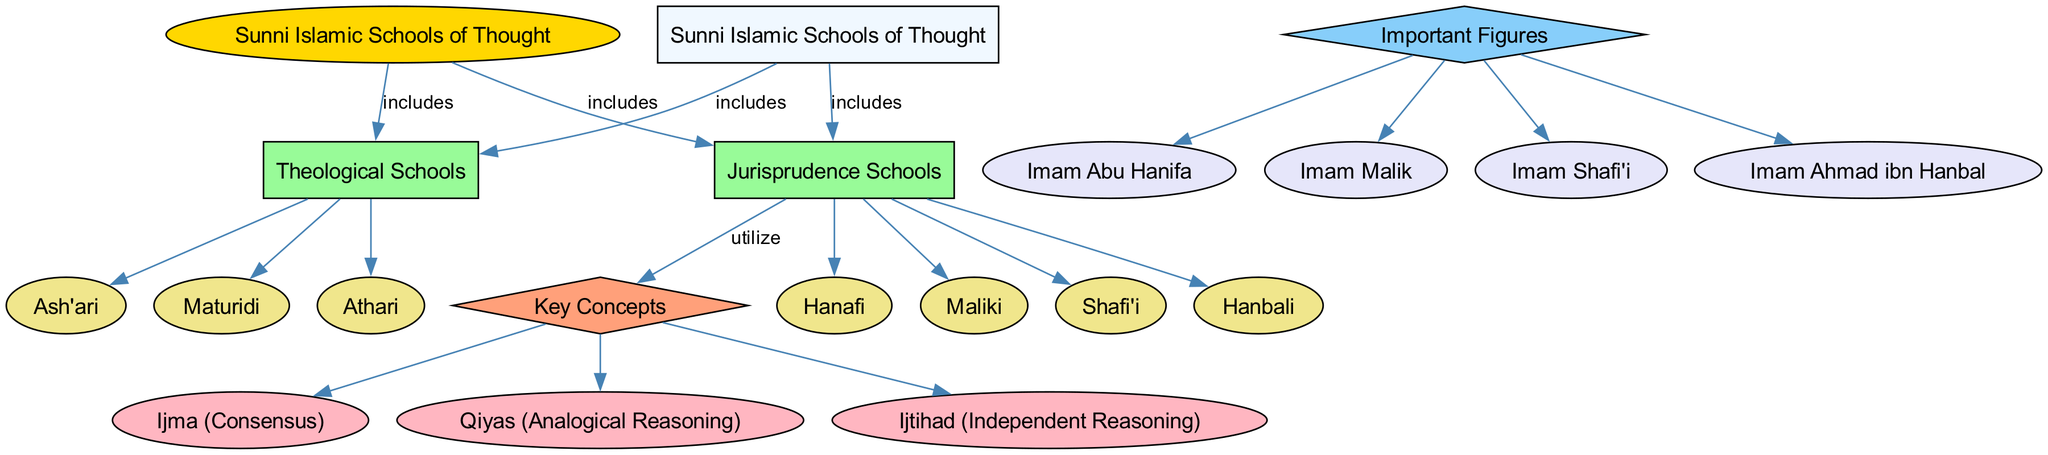What is the central concept of the diagram? The diagram's central concept is prominently positioned and labeled as "Sunni Islamic Schools of Thought." It serves as the main focal point from which other branches extend.
Answer: Sunni Islamic Schools of Thought How many main branches are included in the diagram? By counting the branches that stem from the central concept, there are two main branches: "Theological Schools" and "Jurisprudence Schools."
Answer: 2 Which school is categorized under Theological Schools? The subtypes listed under Theological Schools include "Ash'ari," "Maturidi," and "Athari." One of these subtypes is "Ash'ari," which is a clear answer to the question.
Answer: Ash'ari What are the key concepts utilized by Jurisprudence Schools? The relationships indicated in the diagram show that Jurisprudence Schools utilize key concepts such as "Ijma (Consensus)," "Qiyas (Analogical Reasoning)," and "Ijtihad (Independent Reasoning)." A straightforward answer from this list is one of the key concepts, such as "Ijma."
Answer: Ijma (Consensus) Who is a prominent figure associated with the Hanbali School? Looking at the segment of the diagram that lists important figures, "Imam Ahmad ibn Hanbal" is specifically linked to the Hanbali School, representing a key individual from that school of thought.
Answer: Imam Ahmad ibn Hanbal What type of relationship exists between the Sunni Islamic Schools of Thought and Theological Schools? The diagram illustrates a directed relationship labeled "includes" between the central concept of Sunni Islamic Schools of Thought and the branch of Theological Schools. This clearly indicates that one encompasses the other.
Answer: includes What color represents the Theological Schools in the diagram? The color shown in the diagram for the Theological Schools is a shade of green, specifically '#98FB98,' which can be observed in the rectangular nodes representing these branches.
Answer: green List all the schools under Jurisprudence Schools. The diagram directly lists the subtypes under Jurisprudence Schools, which are "Hanafi," "Maliki," "Shafi'i," and "Hanbali." A concise way to answer is to summarize them simply.
Answer: Hanafi, Maliki, Shafi'i, Hanbali 